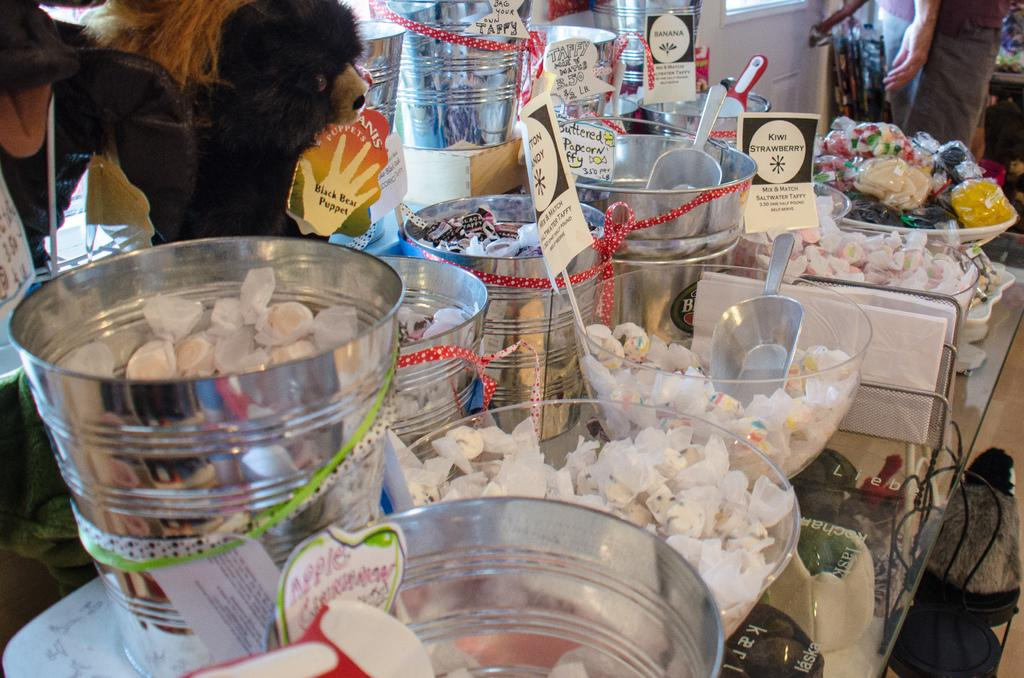What is inside the container in the image? There are different objects in a container in the image. Can you describe the person in the image? There is a person in the image, but no specific details about their appearance or actions are provided. What type of toy is visible in the image? There is a toy in the image, but no specific details about the toy are provided. What is the color of the moon in the image? There is no moon present in the image. Is the alley visible in the image? There is no alley present in the image. 